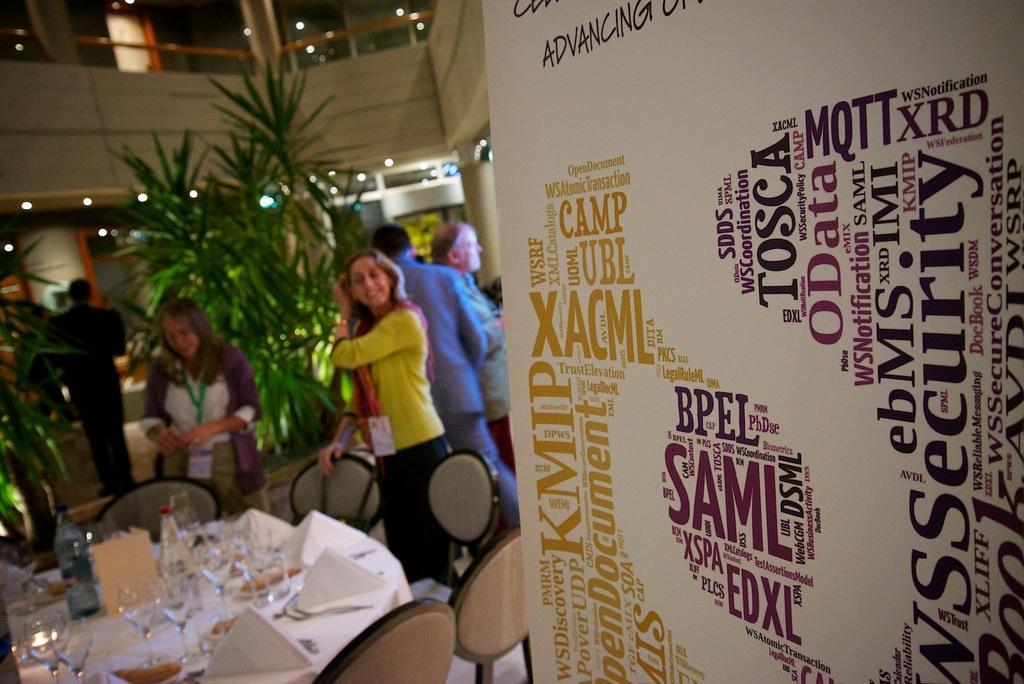Describe this image in one or two sentences. Here in this picture we can see number of people standing on the floor over there and we can see chairs with table in front of it having glasses, bottles and tissue papers on it over there and we can also see plants present over there and in the front we can see a banner present and we can see lights present on the roof over there. 